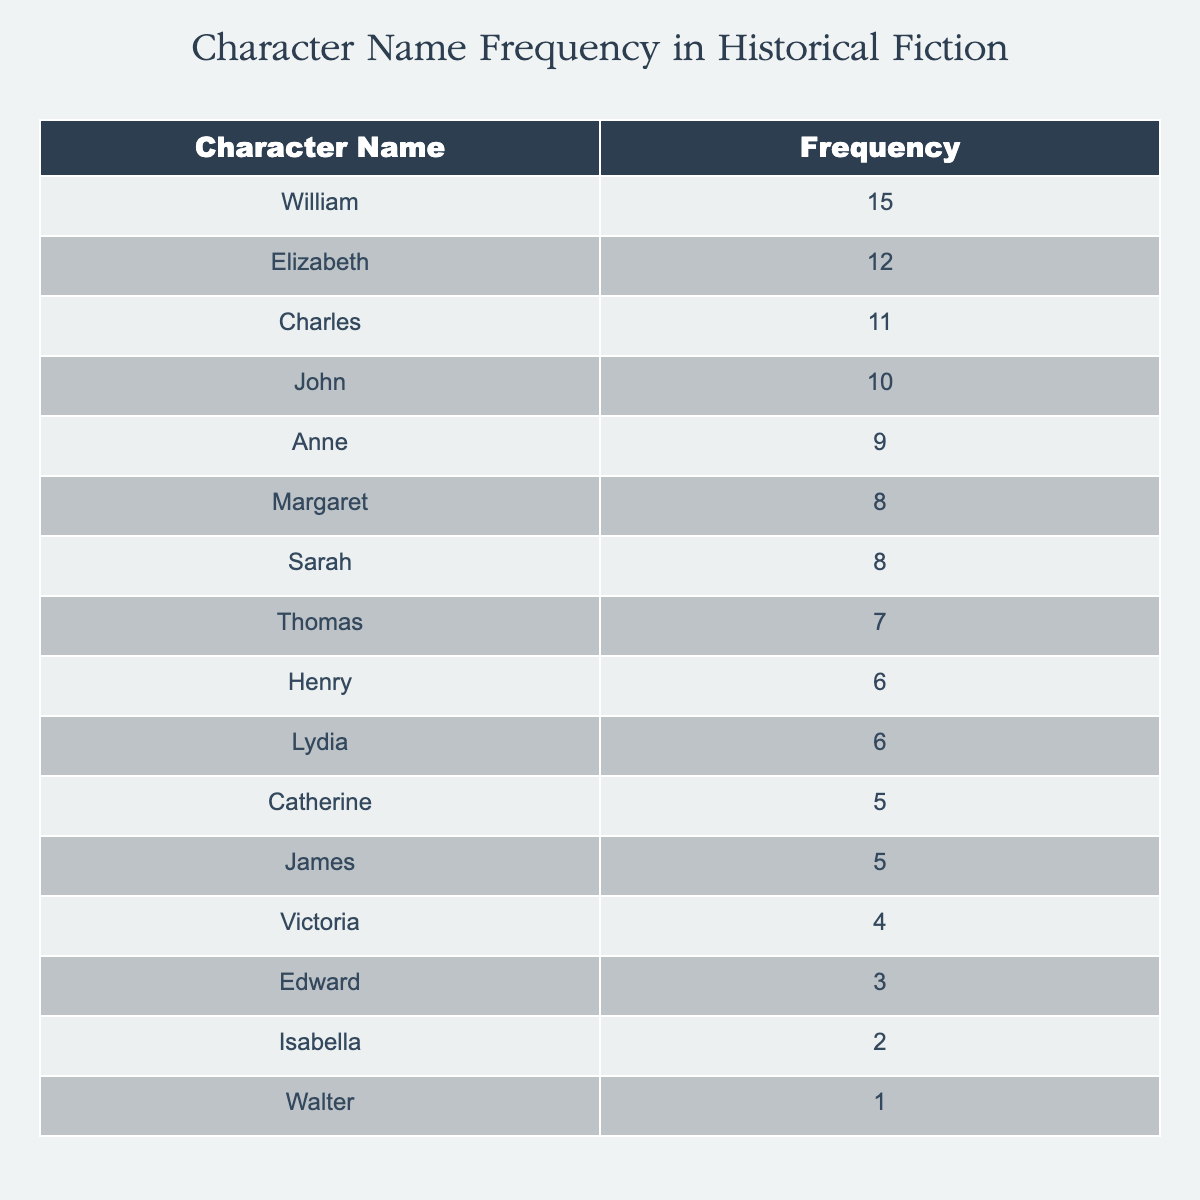What is the frequency of the character name "William"? The table lists "William" with a frequency of 15.
Answer: 15 Which character name appears the least in the submissions? By inspecting the table, "Walter" has the lowest frequency, which is 1.
Answer: Walter What is the total frequency of characters with names starting with 'C'? The characters starting with 'C' are "Catherine" (5) and "Charles" (11). Their total frequency is 5 + 11 = 16.
Answer: 16 Is "Isabella" more frequent than "Edward"? "Isabella" has a frequency of 2, while "Edward" has a frequency of 3. Since 2 is less than 3, the answer is no.
Answer: No What is the average frequency of all character names in the table? First, sum all frequencies: 15 + 12 + 10 + 8 + 6 + 5 + 7 + 9 + 11 + 4 + 3 + 2 + 5 + 8 + 6 + 1 = 10. The number of character names is 16, so the average frequency is 130 / 16 = 8.125.
Answer: 8.125 What character names have a frequency greater than 10? Referring to the table, "William" (15), "Charles" (11), and "Elizabeth" (12) all have frequencies greater than 10.
Answer: William, Charles, Elizabeth What is the difference in frequency between the most and least frequent character? "William" is the most frequent with 15, and "Walter" is the least frequent with 1. The difference is 15 - 1 = 14.
Answer: 14 Are there any characters with a frequency of 5? Looking at the table, both "Catherine" and "James" have a frequency of 5. Therefore, the answer is yes.
Answer: Yes What is the combined frequency of characters whose names end with 'a'? The characters "Catherine" (5), "Victoria" (4), and "Anne" (9) end with 'a'. Their combined frequency is 5 + 4 + 9 = 18.
Answer: 18 